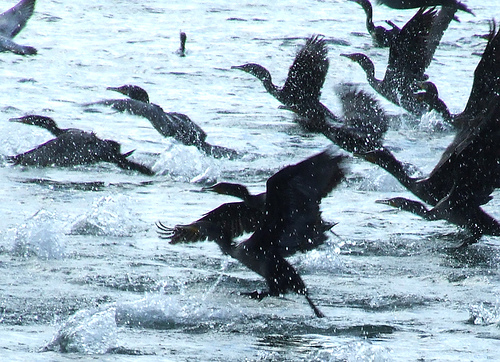Please provide the bounding box coordinate of the region this sentence describes: wings extended above body. The bounding box coordinates for the region describing 'wings extended above body' are [0.68, 0.14, 0.91, 0.41]. This region captures the specific part of the image where a bird's wings are notably raised above its body. 